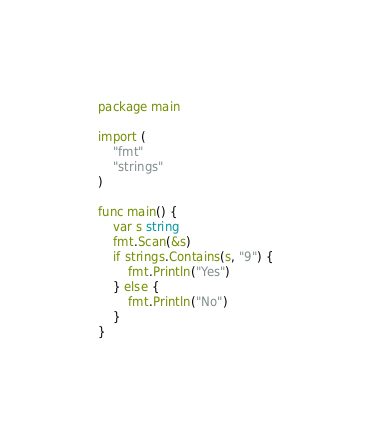<code> <loc_0><loc_0><loc_500><loc_500><_Go_>package main

import (
	"fmt"
	"strings"
)

func main() {
	var s string
	fmt.Scan(&s)
	if strings.Contains(s, "9") {
		fmt.Println("Yes")
	} else {
		fmt.Println("No")
	}
}
</code> 